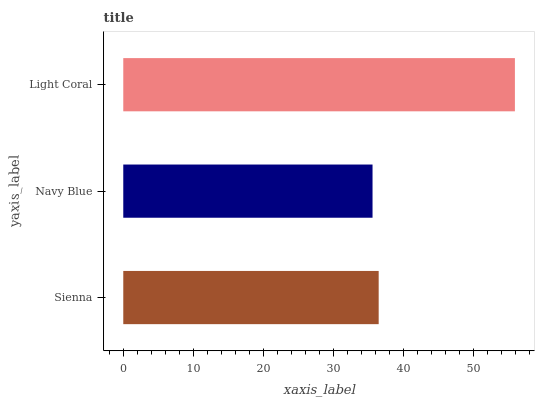Is Navy Blue the minimum?
Answer yes or no. Yes. Is Light Coral the maximum?
Answer yes or no. Yes. Is Light Coral the minimum?
Answer yes or no. No. Is Navy Blue the maximum?
Answer yes or no. No. Is Light Coral greater than Navy Blue?
Answer yes or no. Yes. Is Navy Blue less than Light Coral?
Answer yes or no. Yes. Is Navy Blue greater than Light Coral?
Answer yes or no. No. Is Light Coral less than Navy Blue?
Answer yes or no. No. Is Sienna the high median?
Answer yes or no. Yes. Is Sienna the low median?
Answer yes or no. Yes. Is Navy Blue the high median?
Answer yes or no. No. Is Navy Blue the low median?
Answer yes or no. No. 